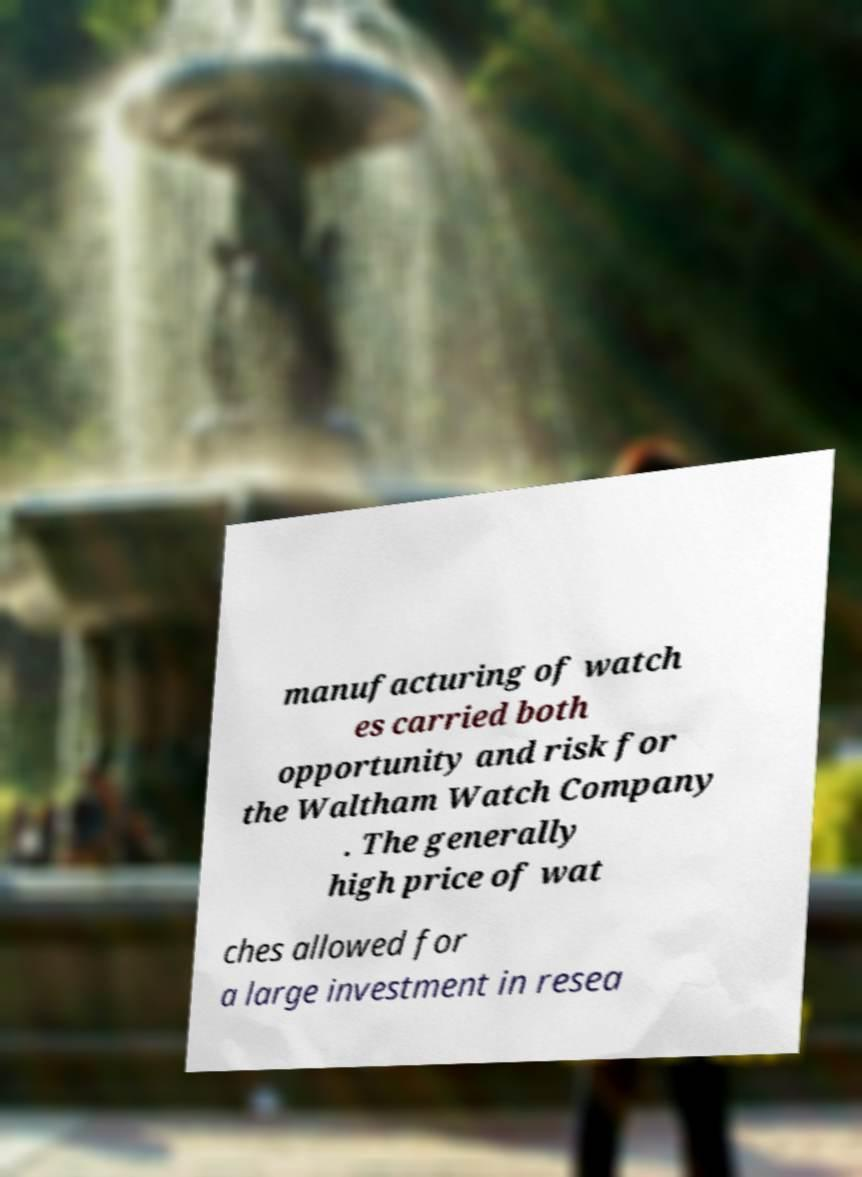I need the written content from this picture converted into text. Can you do that? manufacturing of watch es carried both opportunity and risk for the Waltham Watch Company . The generally high price of wat ches allowed for a large investment in resea 